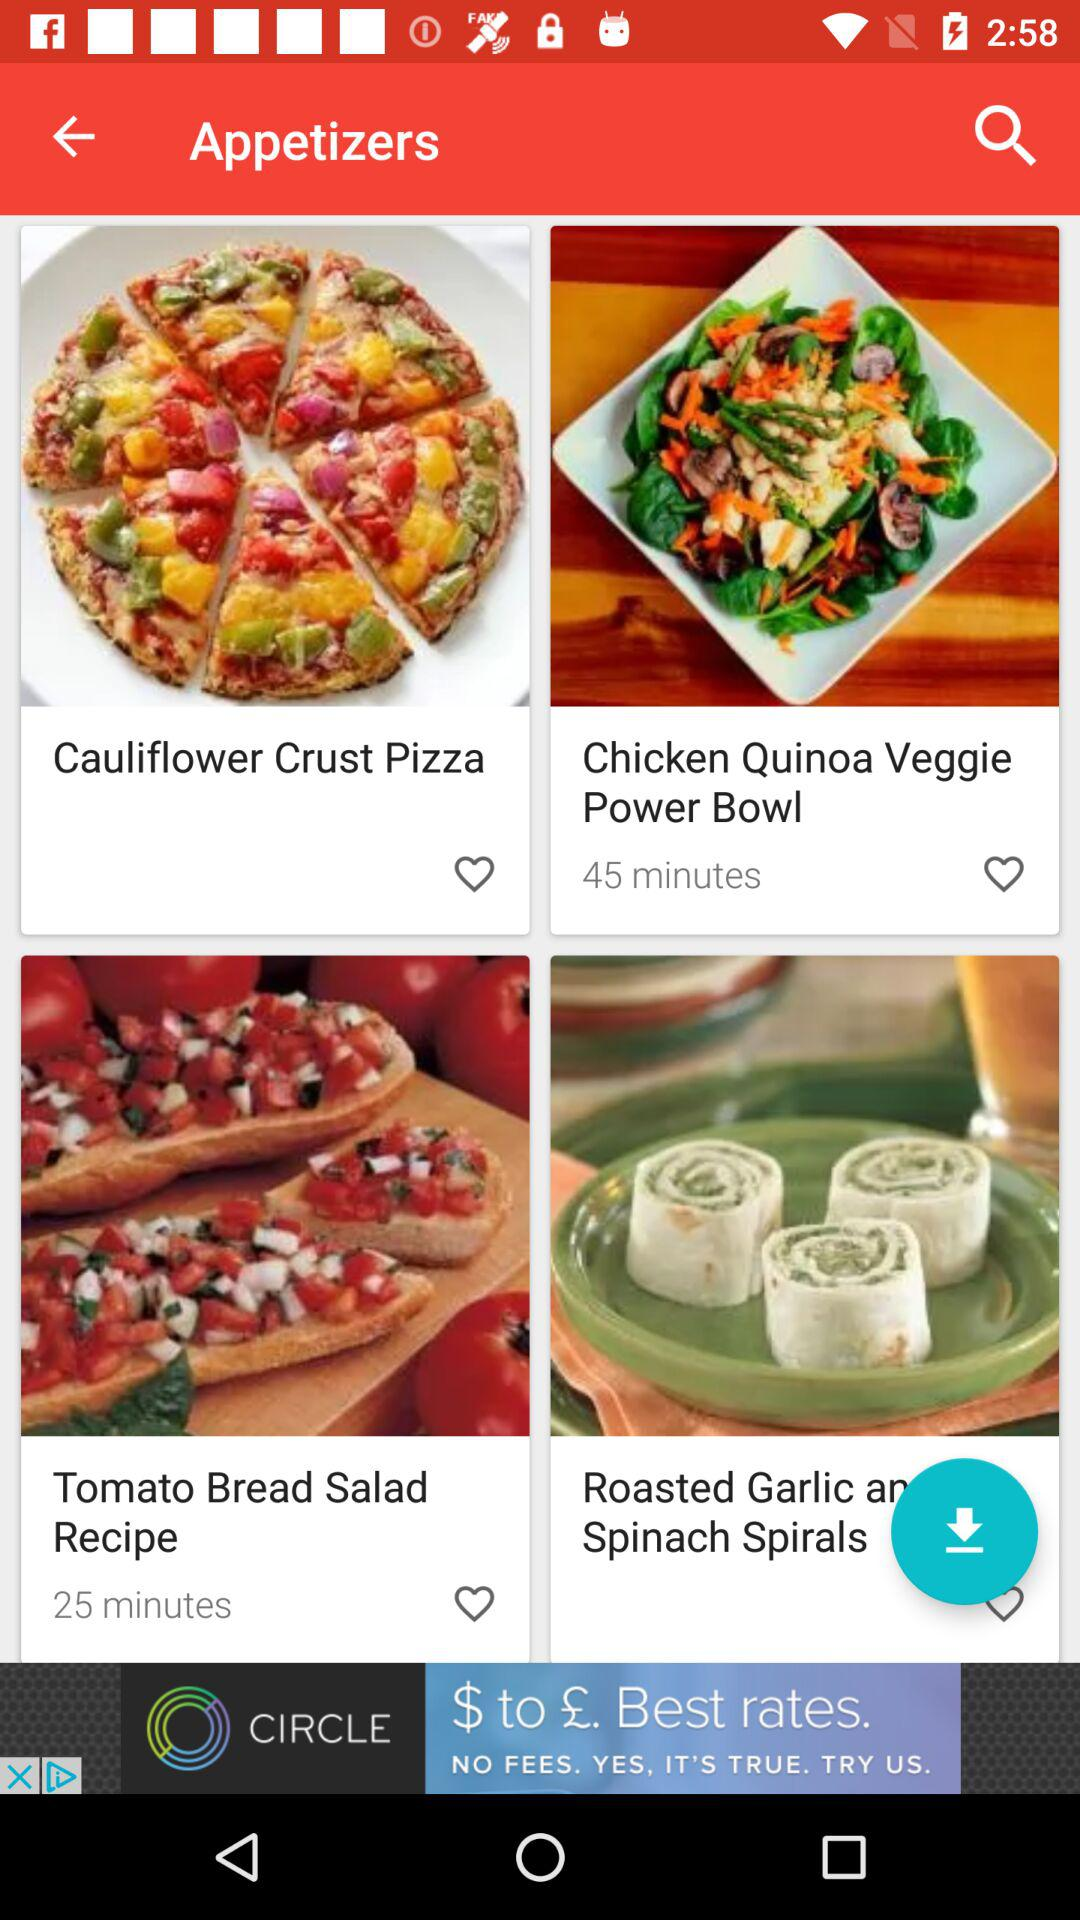"Tomato Bread Salad Recipe" takes how much time to prepare? It takes 25 minutes to prepare. 